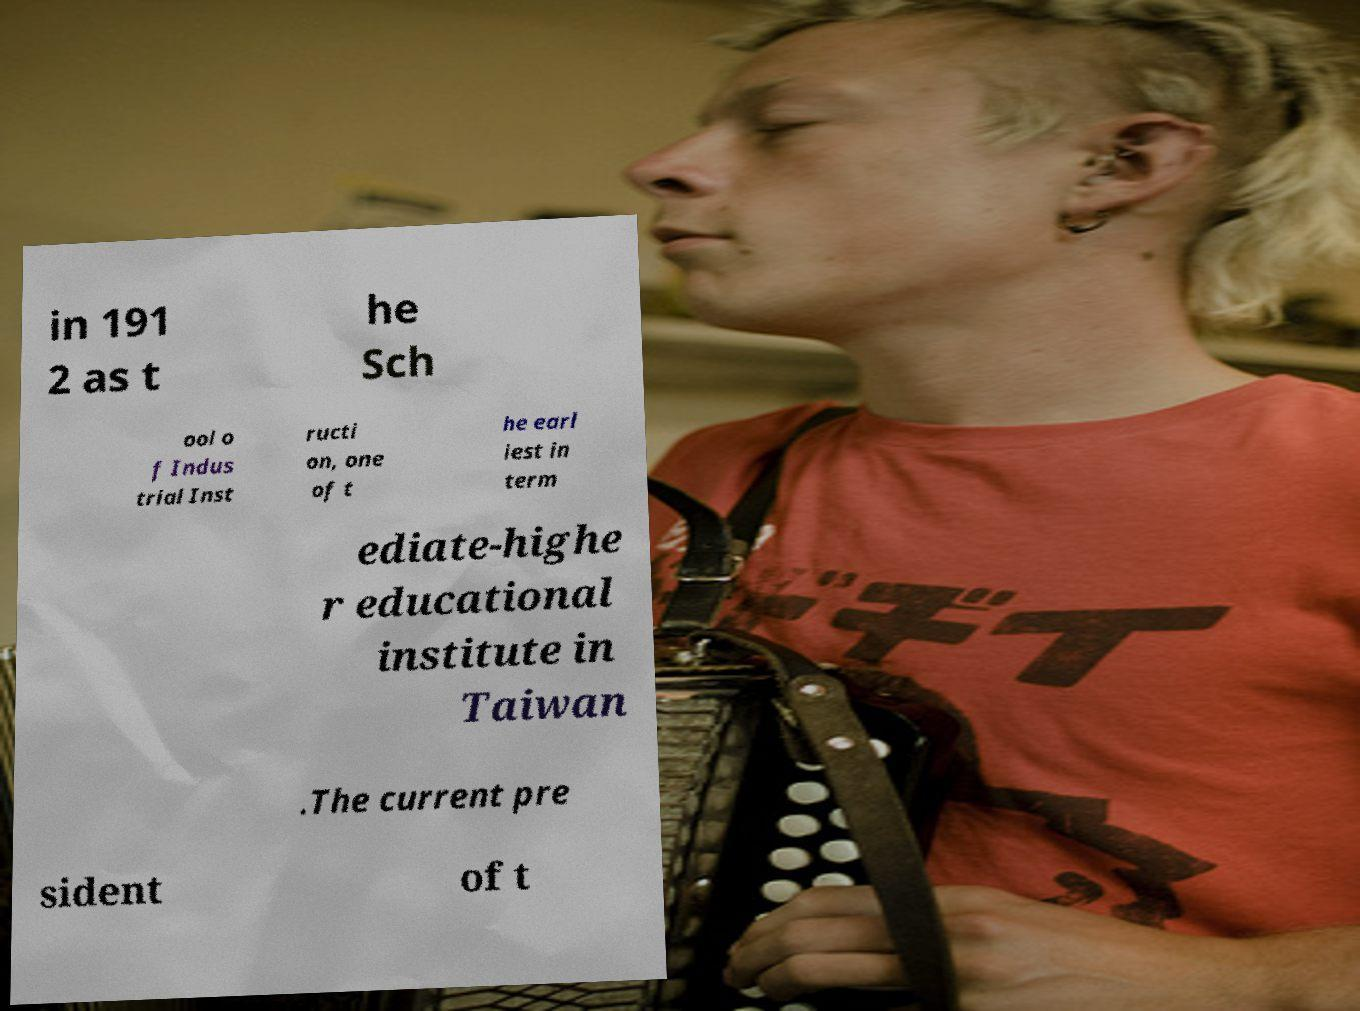For documentation purposes, I need the text within this image transcribed. Could you provide that? in 191 2 as t he Sch ool o f Indus trial Inst ructi on, one of t he earl iest in term ediate-highe r educational institute in Taiwan .The current pre sident of t 